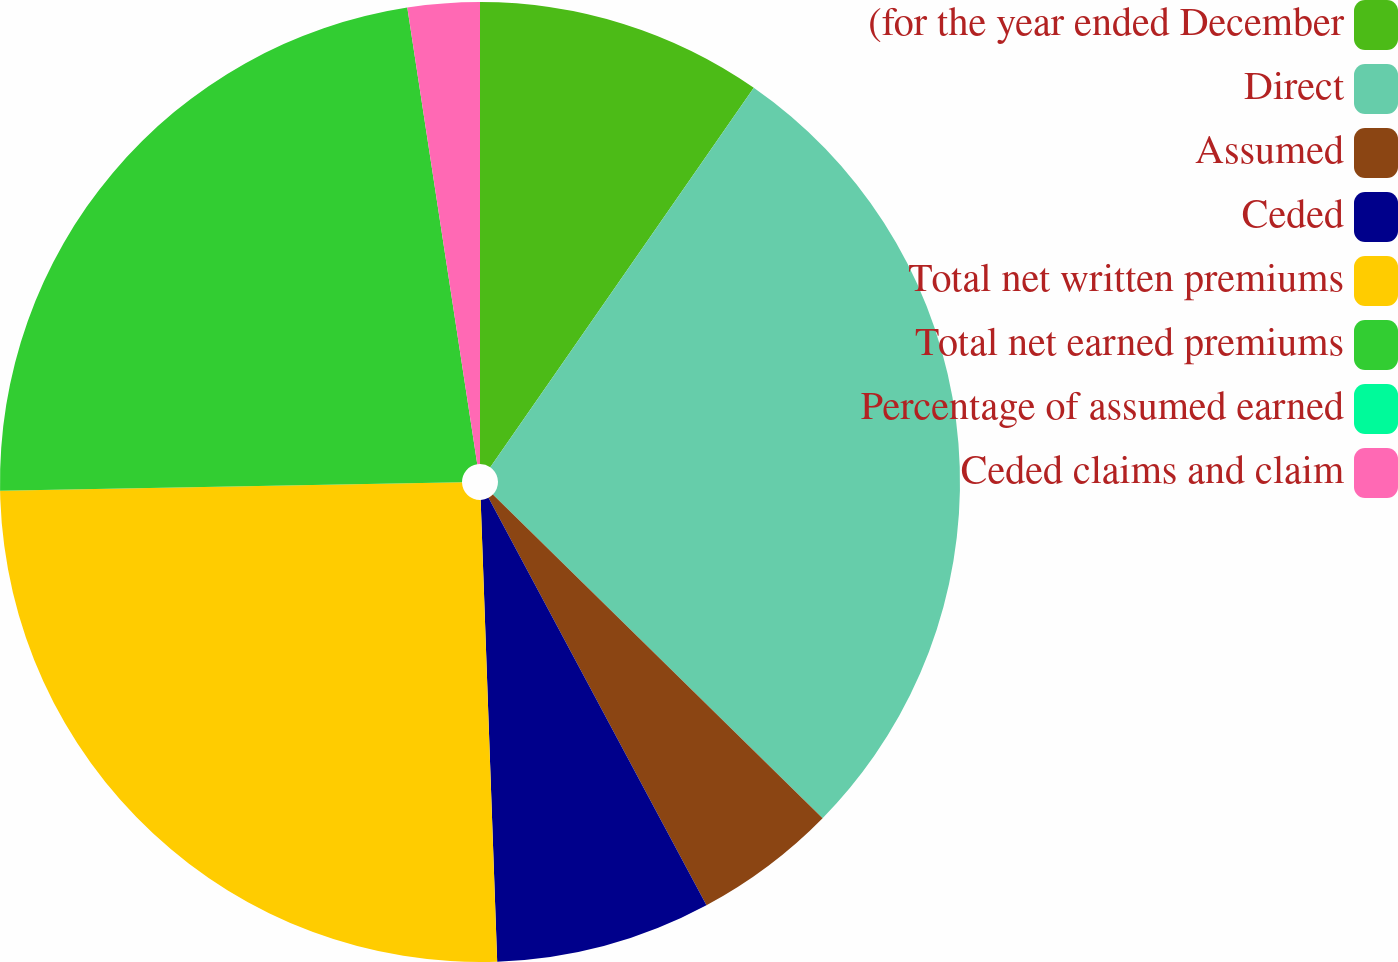<chart> <loc_0><loc_0><loc_500><loc_500><pie_chart><fcel>(for the year ended December<fcel>Direct<fcel>Assumed<fcel>Ceded<fcel>Total net written premiums<fcel>Total net earned premiums<fcel>Percentage of assumed earned<fcel>Ceded claims and claim<nl><fcel>9.66%<fcel>27.69%<fcel>4.83%<fcel>7.25%<fcel>25.28%<fcel>22.87%<fcel>0.0%<fcel>2.42%<nl></chart> 